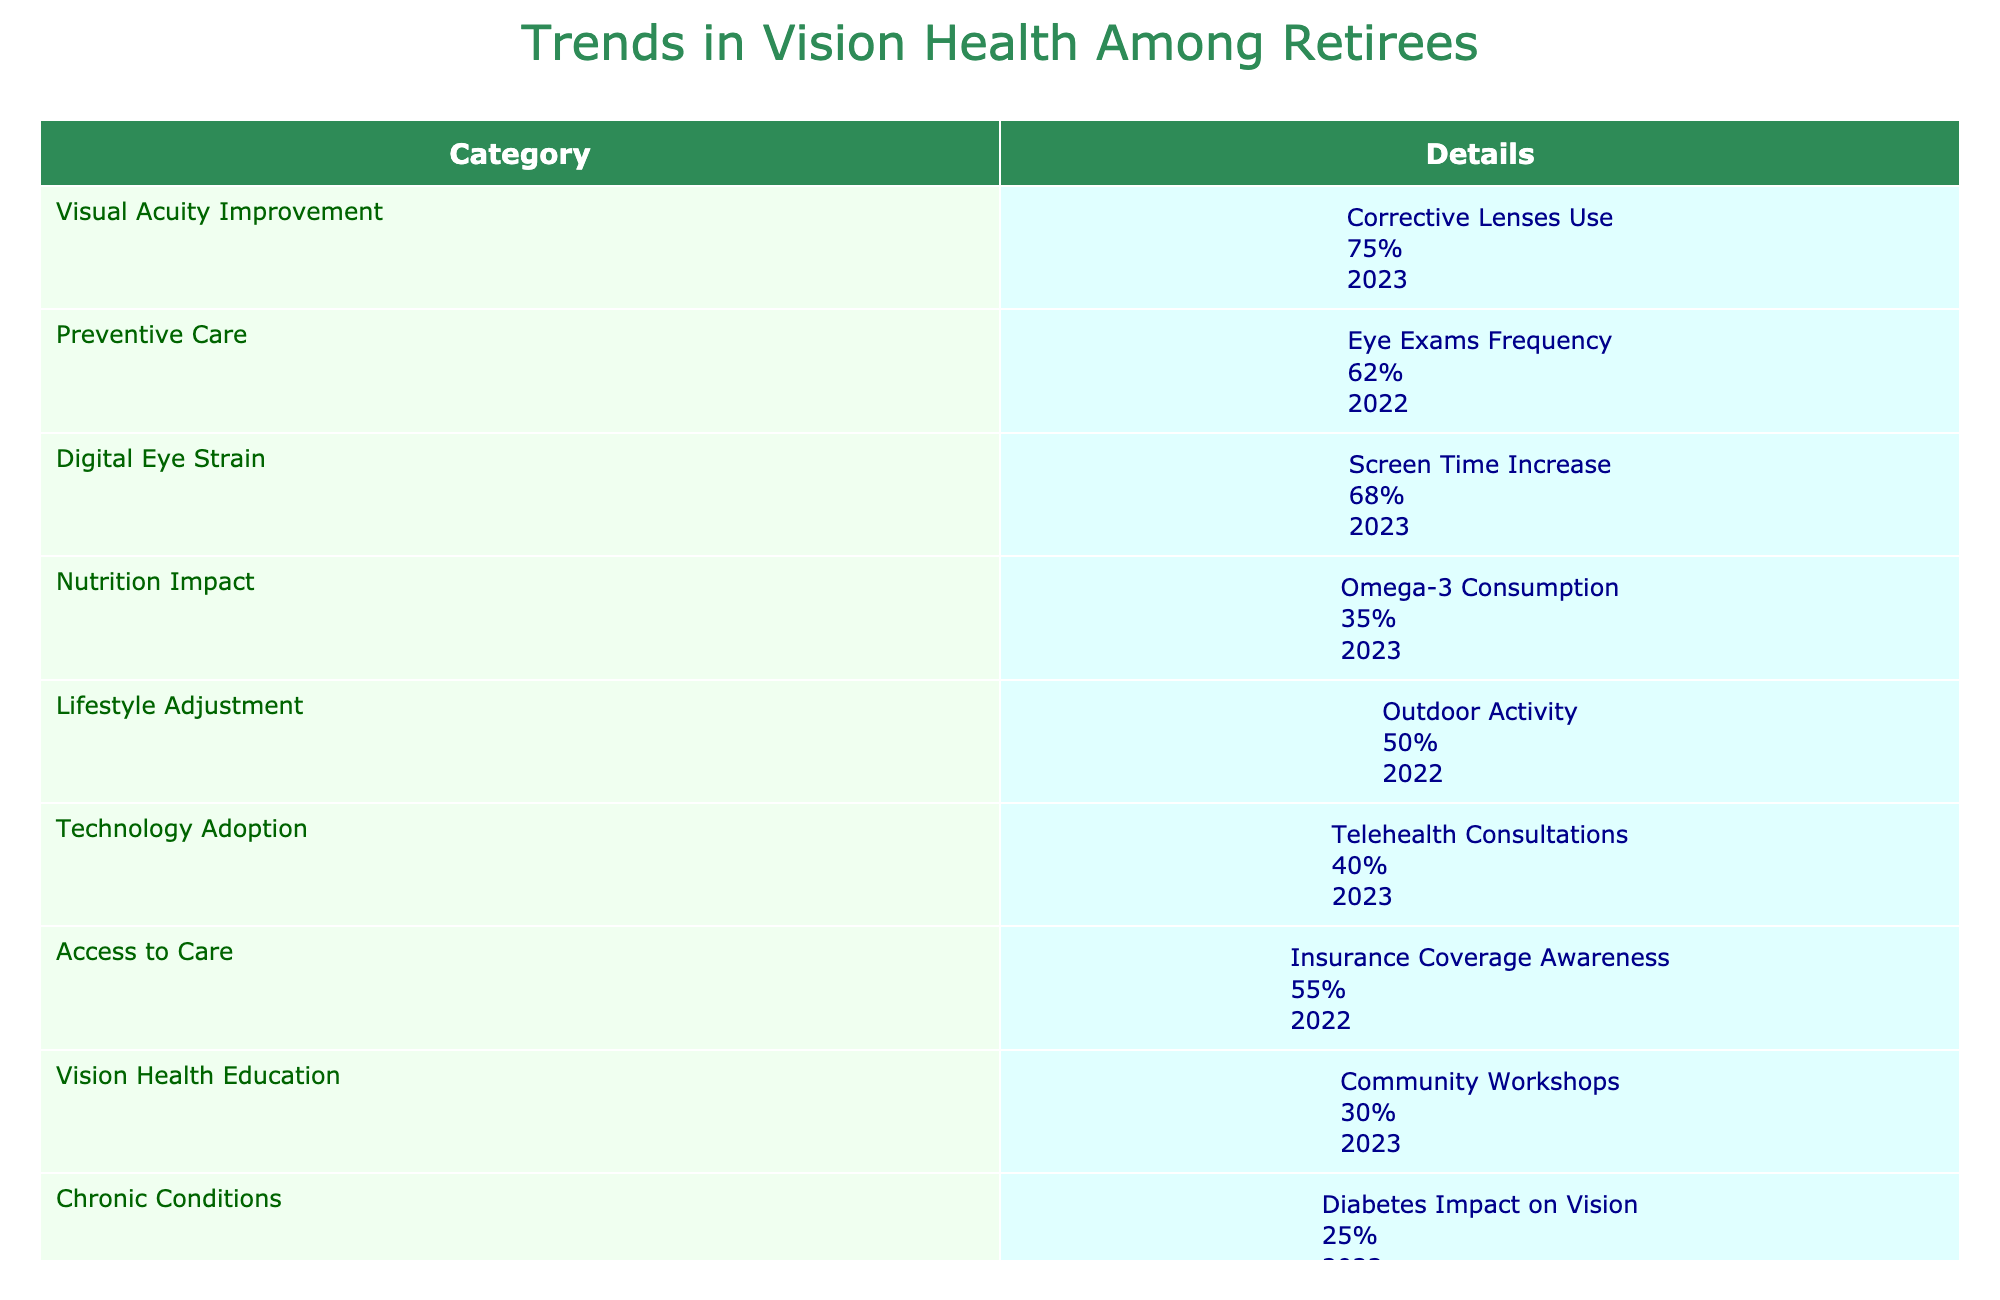What percentage of retirees regularly attend eye exams? The table indicates the percentage of retirees who attend regular eye exams for early detection is stated in the row labeled "Eye Exams Frequency," which shows 62% for the year 2022.
Answer: 62% What trend has the highest percentage of improvement among retirees in 2023? In 2023, the row labeled "Corrective Lenses Use" indicates a 75% improvement in vision among retirees, which is the highest percentage listed for that year.
Answer: 75% Is there a higher percentage of retirees engaging in outdoor activities than those using telehealth consultations in 2023? The table lists 50% of retirees engaging in outdoor activities and 40% utilizing telehealth consultations. Since 50% is greater than 40%, it confirms that more retirees are participating in outdoor activities than using telehealth services.
Answer: Yes What is the percentage difference between the use of corrective lenses and omega-3 consumption? The percentage for corrective lenses use is 75%, and for omega-3 consumption, it's 35%. To find the difference, subtract 35 from 75, resulting in a difference of 40%.
Answer: 40% How many categories have a percentage above 50% for retirees in 2023? By examining the table, we see "Corrective Lenses Use" at 75%, "Screen Time Increase" at 68%, and "Outdoor Activity" at 50%. This provides a total of three categories with percentages over 50%.
Answer: 3 What percentage of retirees report vision issues linked to diabetes? Looking at the category "Diabetes Impact on Vision," the table shows that 25% of retirees report vision issues related to diabetes.
Answer: 25% Is the upcoming trend in vision health education through community workshops positively influencing overall statistics? The table shows a 30% uptake in community workshops, but without further data directly correlating this to overall statistics, an affirmative conclusion cannot be deduced strictly from the table.
Answer: Not enough information Which group has the lowest percentage linked to chronic conditions affecting vision health? The category "Chronic Conditions" indicates that 25% of retirees report vision issues due to diabetes. This is the lowest percentage when compared to other categories listed.
Answer: 25% 